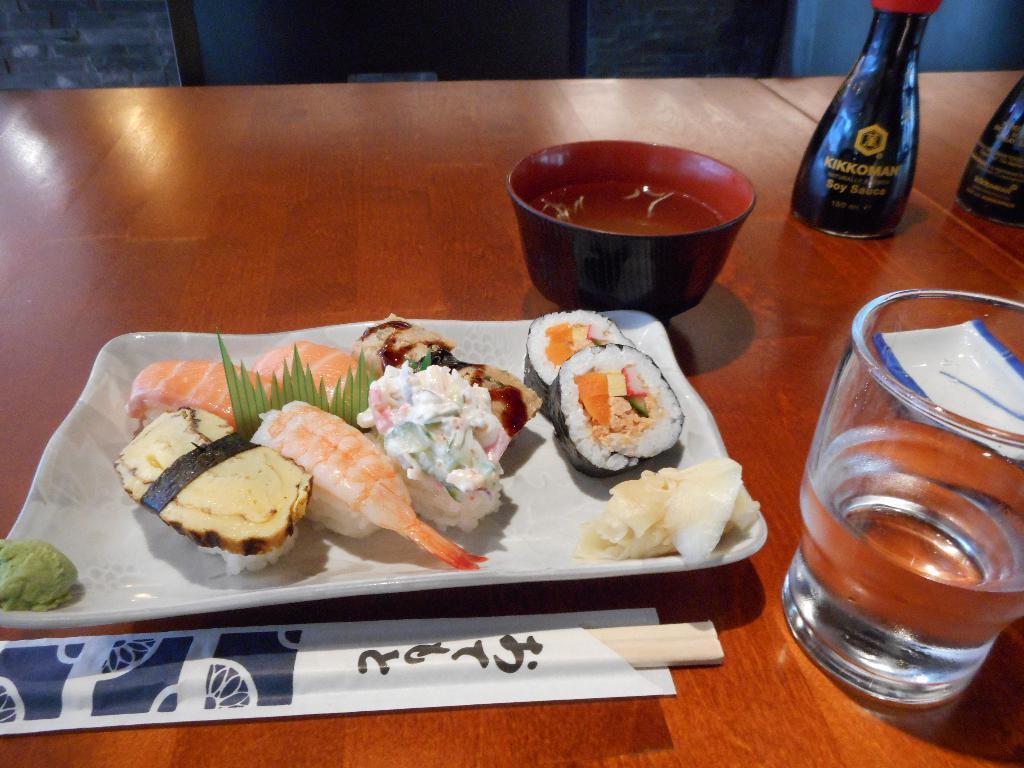Describe this image in one or two sentences. In this image, we can see bottles, a glass with water and there is a bowl, a tray and there are food items and some other objects on the table. In the background, there is a stand. 